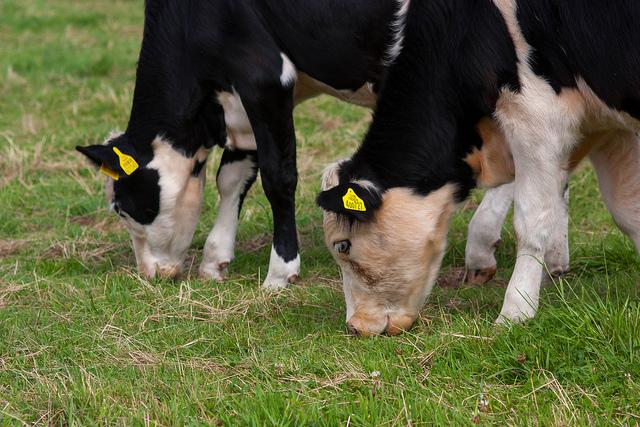Are these milking cows?
Answer briefly. No. What color are the tags in the ears?
Give a very brief answer. Yellow. What color is the cow?
Quick response, please. Black and white. Do the cows have tags?
Keep it brief. Yes. Do these cows belong to a farmer?
Quick response, please. Yes. 